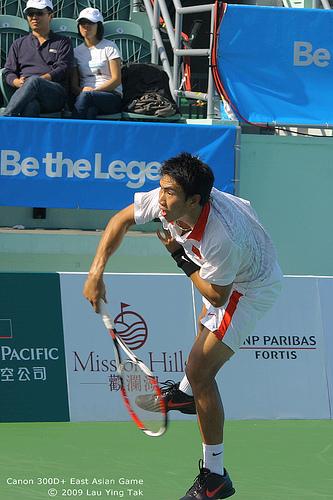Are the spectator's legs crossed the same way?
Answer briefly. Yes. What color is the man's shoes?
Short answer required. Black. Is the player's goal to meet the ball at eye level?
Short answer required. No. 